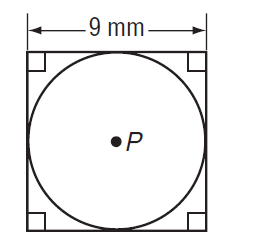Question: Find the exact circumference of the circle.
Choices:
A. 4.5 \pi
B. 9 \pi
C. 18 \pi
D. 81 \pi
Answer with the letter. Answer: B 